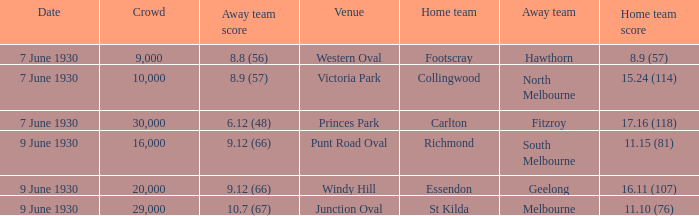What is the smallest crowd to see the away team score 10.7 (67)? 29000.0. 